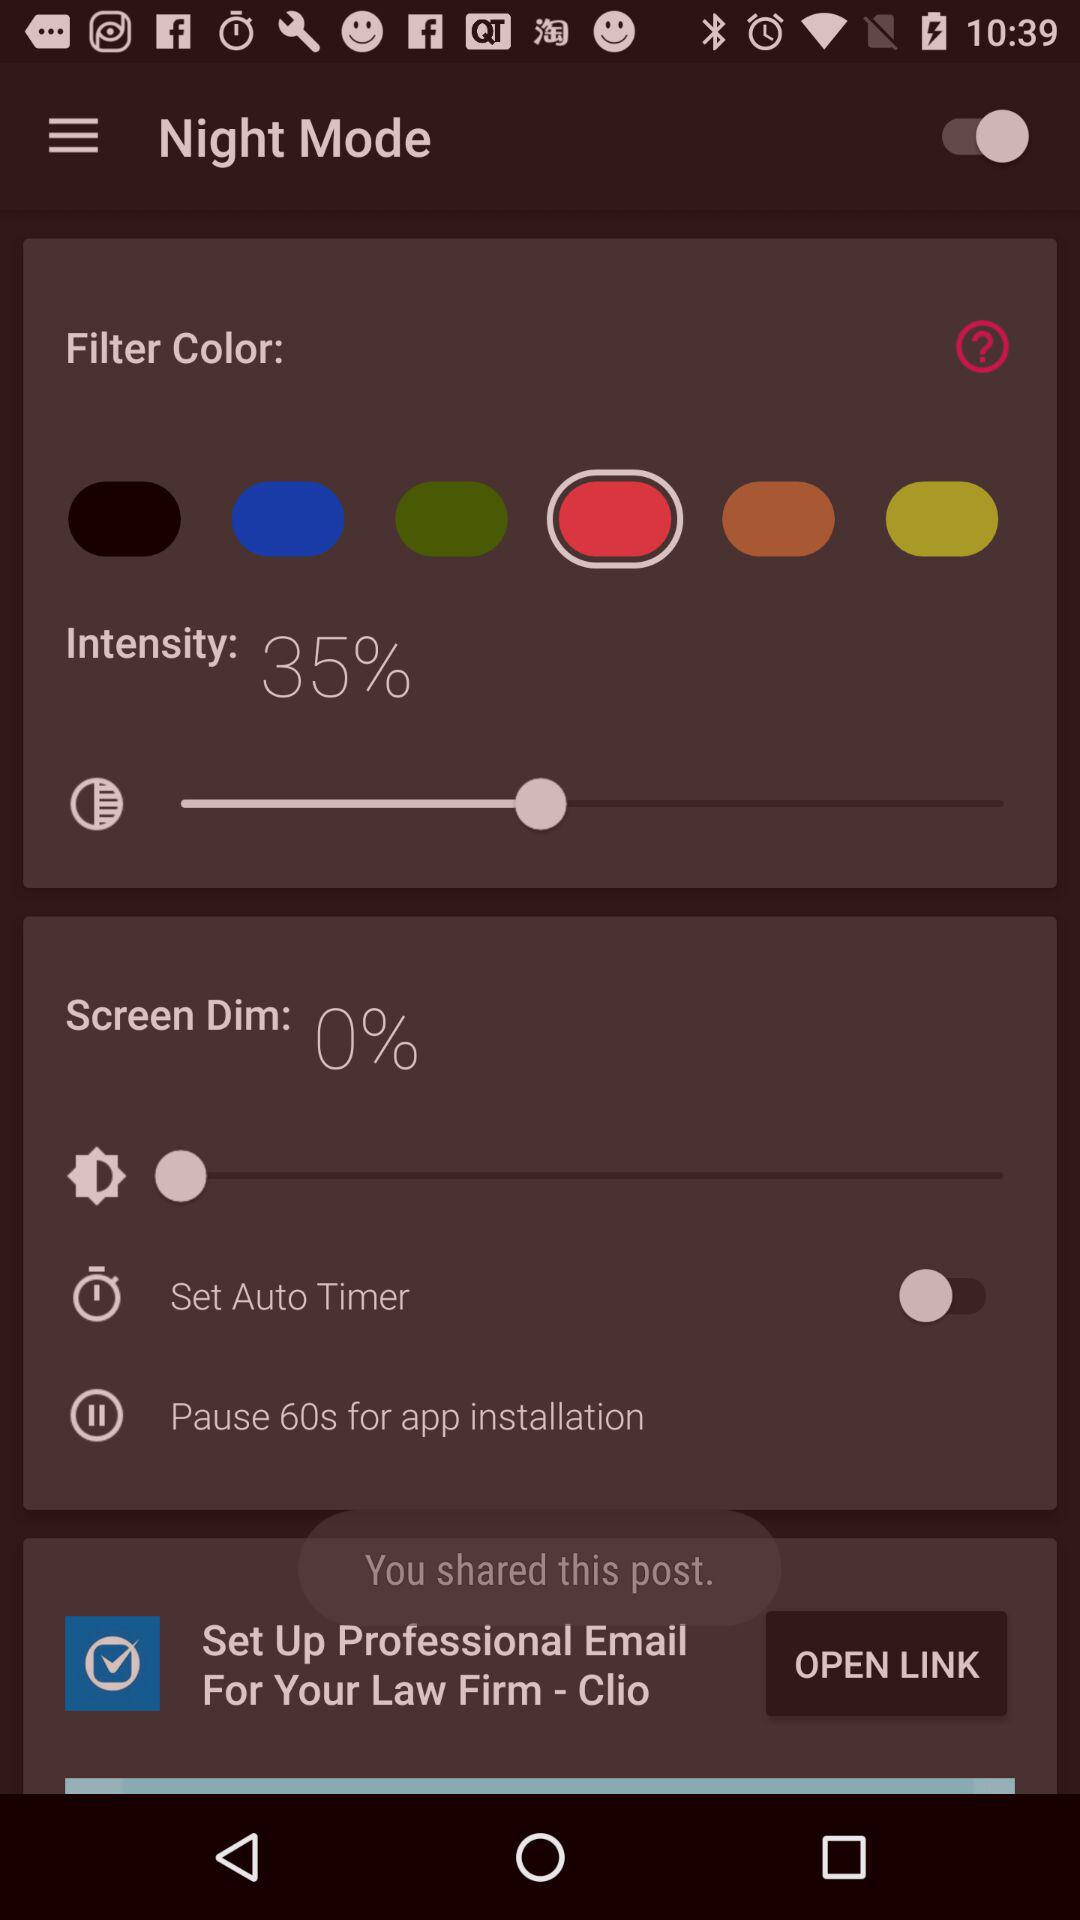How much is the percentage of screen dim? The percentage of screen dim is 0. 